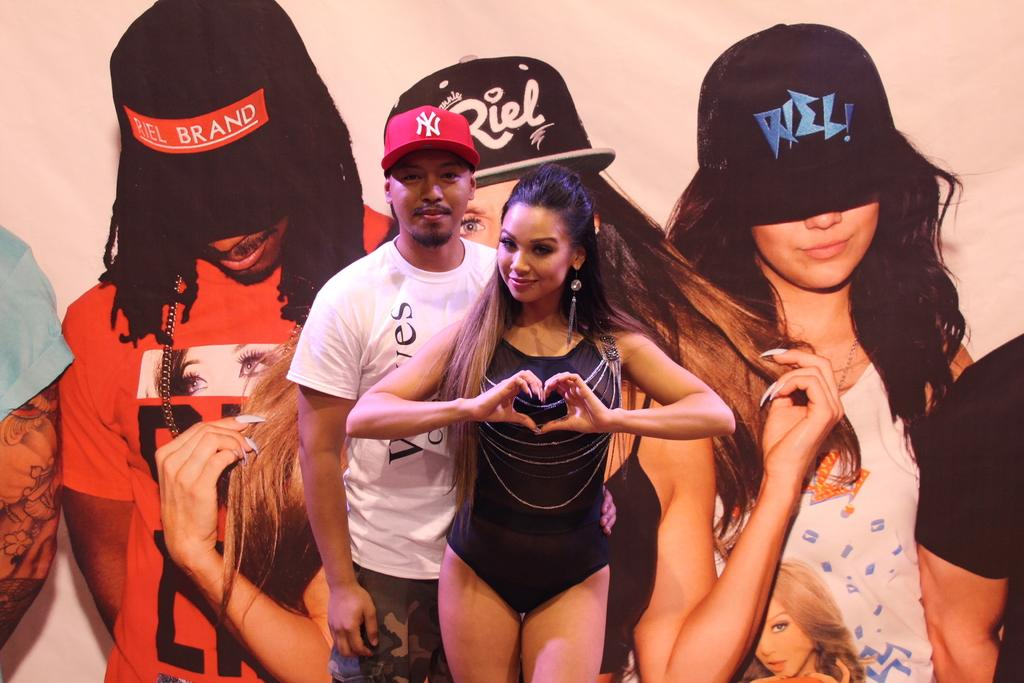How many people are in the image? There are two people in the image. Can you describe the people in the image? The people in the image are a man and a woman. What are the people doing in the image? The man and woman are standing and smiling. What type of image is this? The image appears to be a wall poster. What are the people wearing on their heads in the image? The people in the poster are wearing hats. What type of badge is the beginner wearing in the image? There is no badge or beginner present in the image. How does the man use the comb in the image? There is no comb present in the image. 